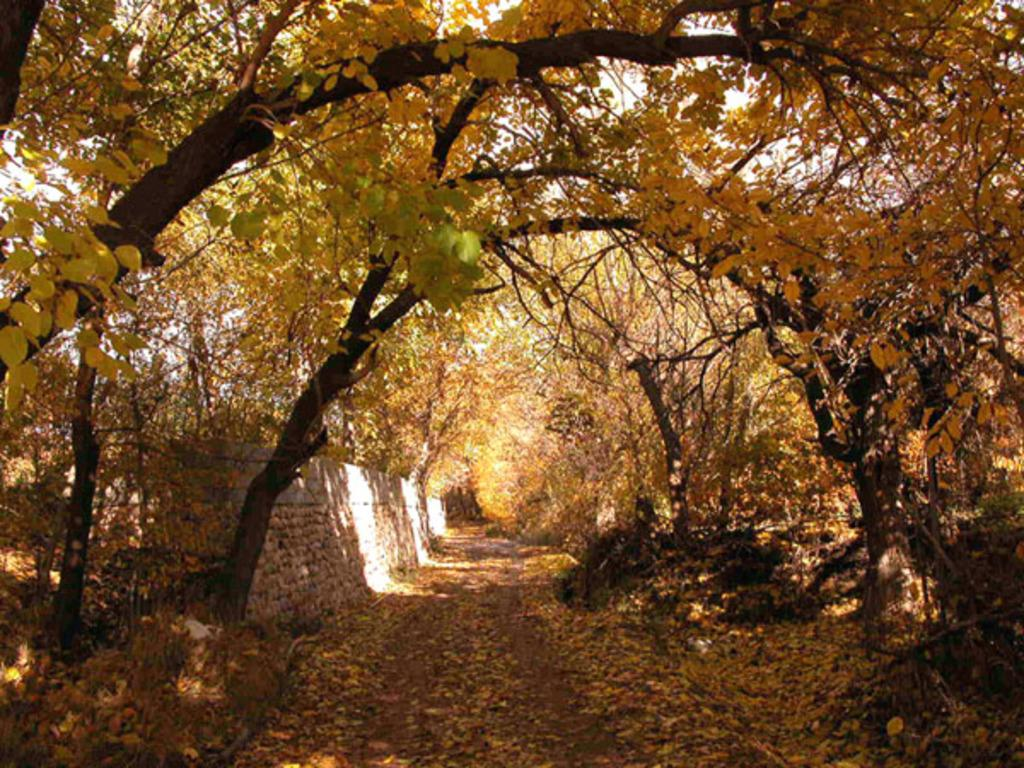What type of vegetation can be seen in the image? There are trees in the image. What is located on the left side of the image? There is a wall on the left side of the image. What is present on the ground in the image? There are leaves on the ground in the image. What is visible in the background of the image? The sky is visible in the image. Can you see a cup being used by a bee to play baseball in the image? There is no cup, bee, or baseball present in the image. 